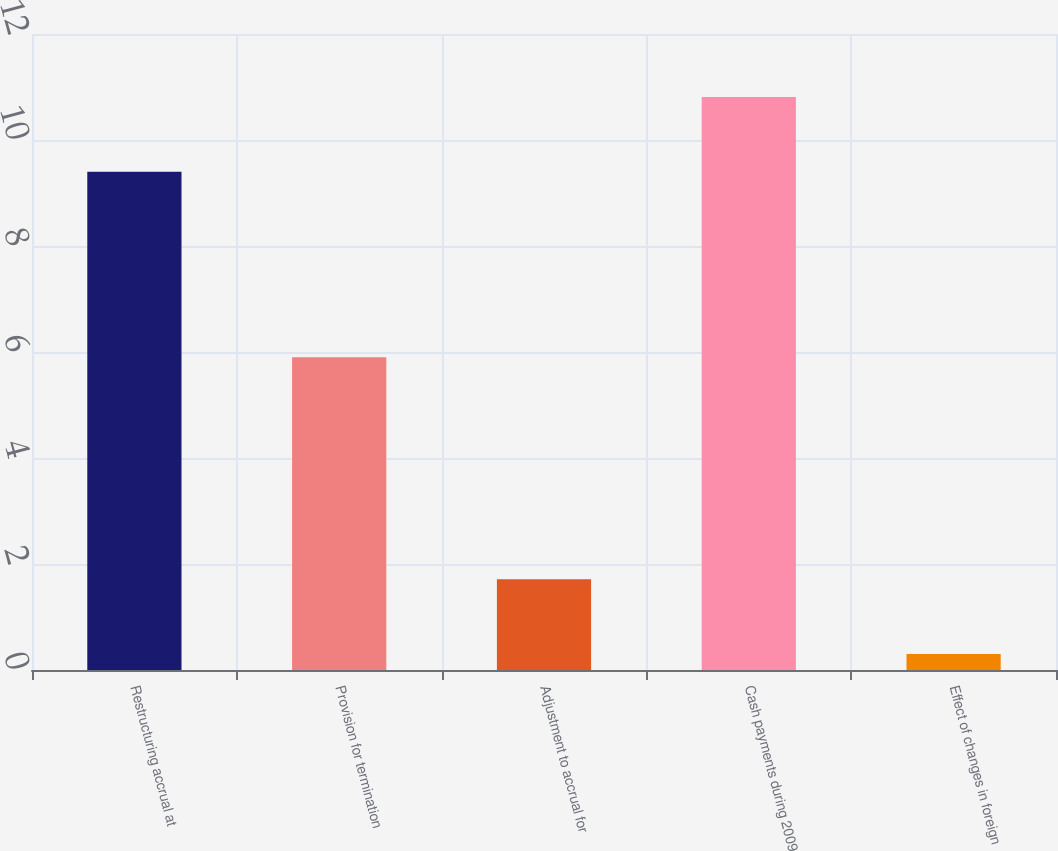<chart> <loc_0><loc_0><loc_500><loc_500><bar_chart><fcel>Restructuring accrual at<fcel>Provision for termination<fcel>Adjustment to accrual for<fcel>Cash payments during 2009<fcel>Effect of changes in foreign<nl><fcel>9.4<fcel>5.9<fcel>1.71<fcel>10.81<fcel>0.3<nl></chart> 